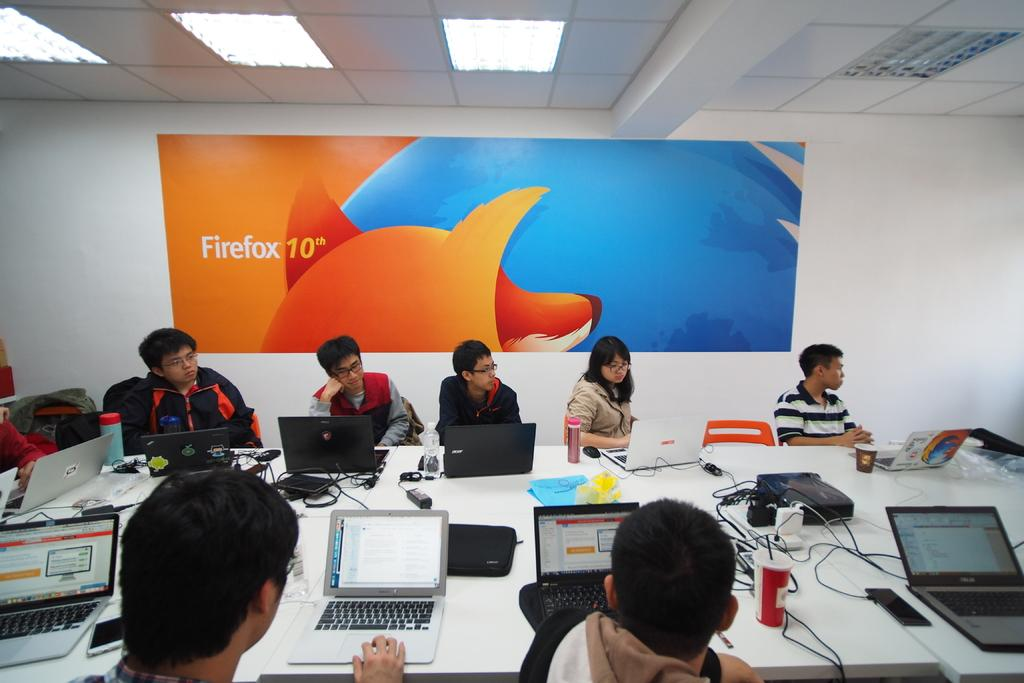<image>
Offer a succinct explanation of the picture presented. A group of students with computers around a table with a banner advertising Firefox 10. 